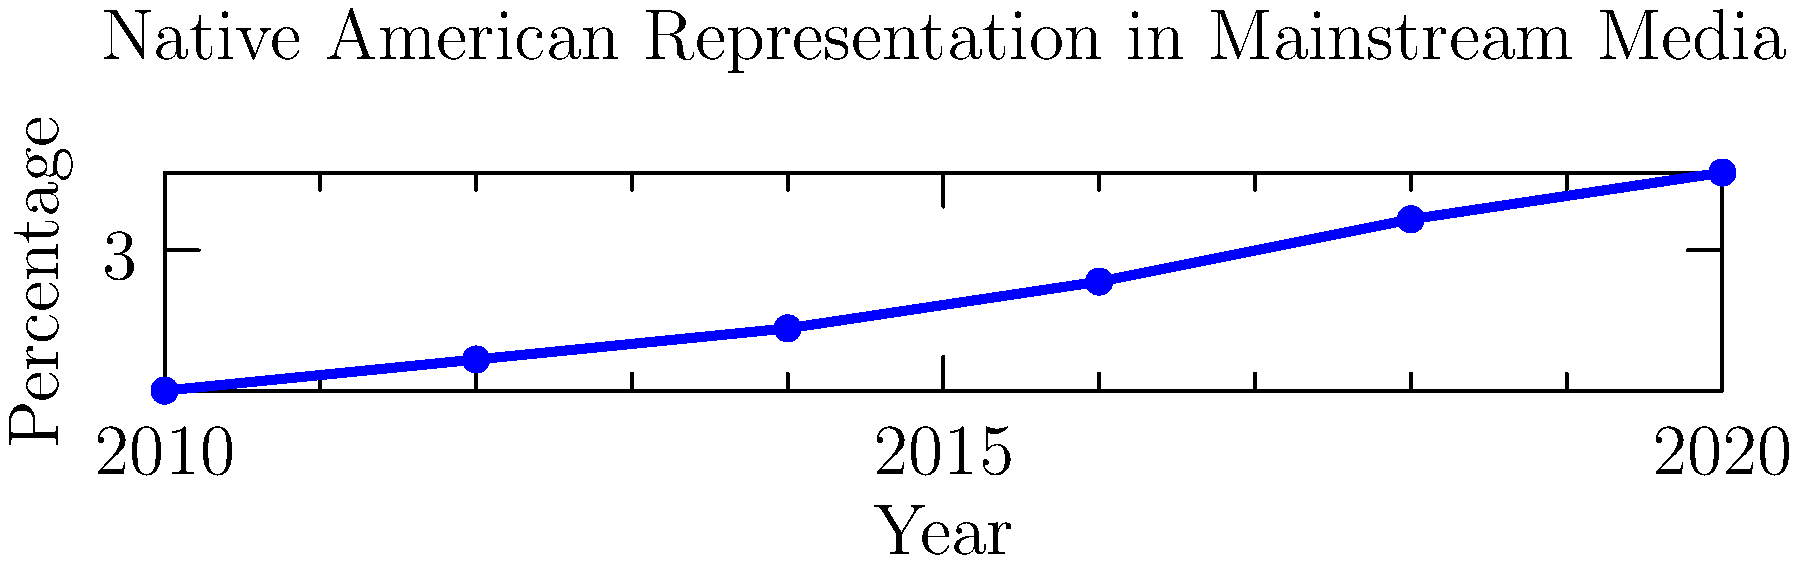Analyze the trend in Native American representation in mainstream media shown in the graph. What factors might contribute to this trend, and how could this impact the public perception of indigenous communities? Discuss potential strategies to improve representation and challenge stereotypes in media portrayals. To analyze this trend and its implications, let's break it down step-by-step:

1. Trend observation: The graph shows a steady increase in Native American representation in mainstream media from 2010 to 2020, rising from about 2.1% to 3.5%.

2. Contributing factors:
   a) Increased awareness of diversity and inclusion issues in media
   b) Advocacy efforts by Native American organizations and allies
   c) Growing interest in indigenous cultures and histories
   d) Emergence of Native American filmmakers, writers, and content creators

3. Impact on public perception:
   a) Increased visibility can lead to greater awareness of indigenous issues
   b) More diverse portrayals may help challenge stereotypes
   c) However, the quality of representation is as important as quantity

4. Potential strategies for improvement:
   a) Promote Native American creators in key media roles (writers, directors, producers)
   b) Implement cultural sensitivity training in media production
   c) Encourage consultation with tribal representatives for accurate portrayals
   d) Support independent Native American media outlets and productions
   e) Advocate for more nuanced and contemporary representations of indigenous life

5. Challenging stereotypes:
   a) Showcase diverse Native American experiences, including urban and contemporary contexts
   b) Avoid relegating Native characters to historical settings only
   c) Develop complex, multi-dimensional Native characters in lead roles
   d) Address and deconstruct common stereotypes through thoughtful storytelling

6. Long-term goals:
   a) Achieve proportional representation in media (Native Americans comprise about 2% of the US population)
   b) Foster a media landscape that accurately reflects the diversity and complexity of indigenous cultures
   c) Use media as a tool for education and cultural preservation
Answer: Increasing trend in representation; needs continued efforts for accurate, diverse portrayals to challenge stereotypes and improve public understanding of indigenous communities. 